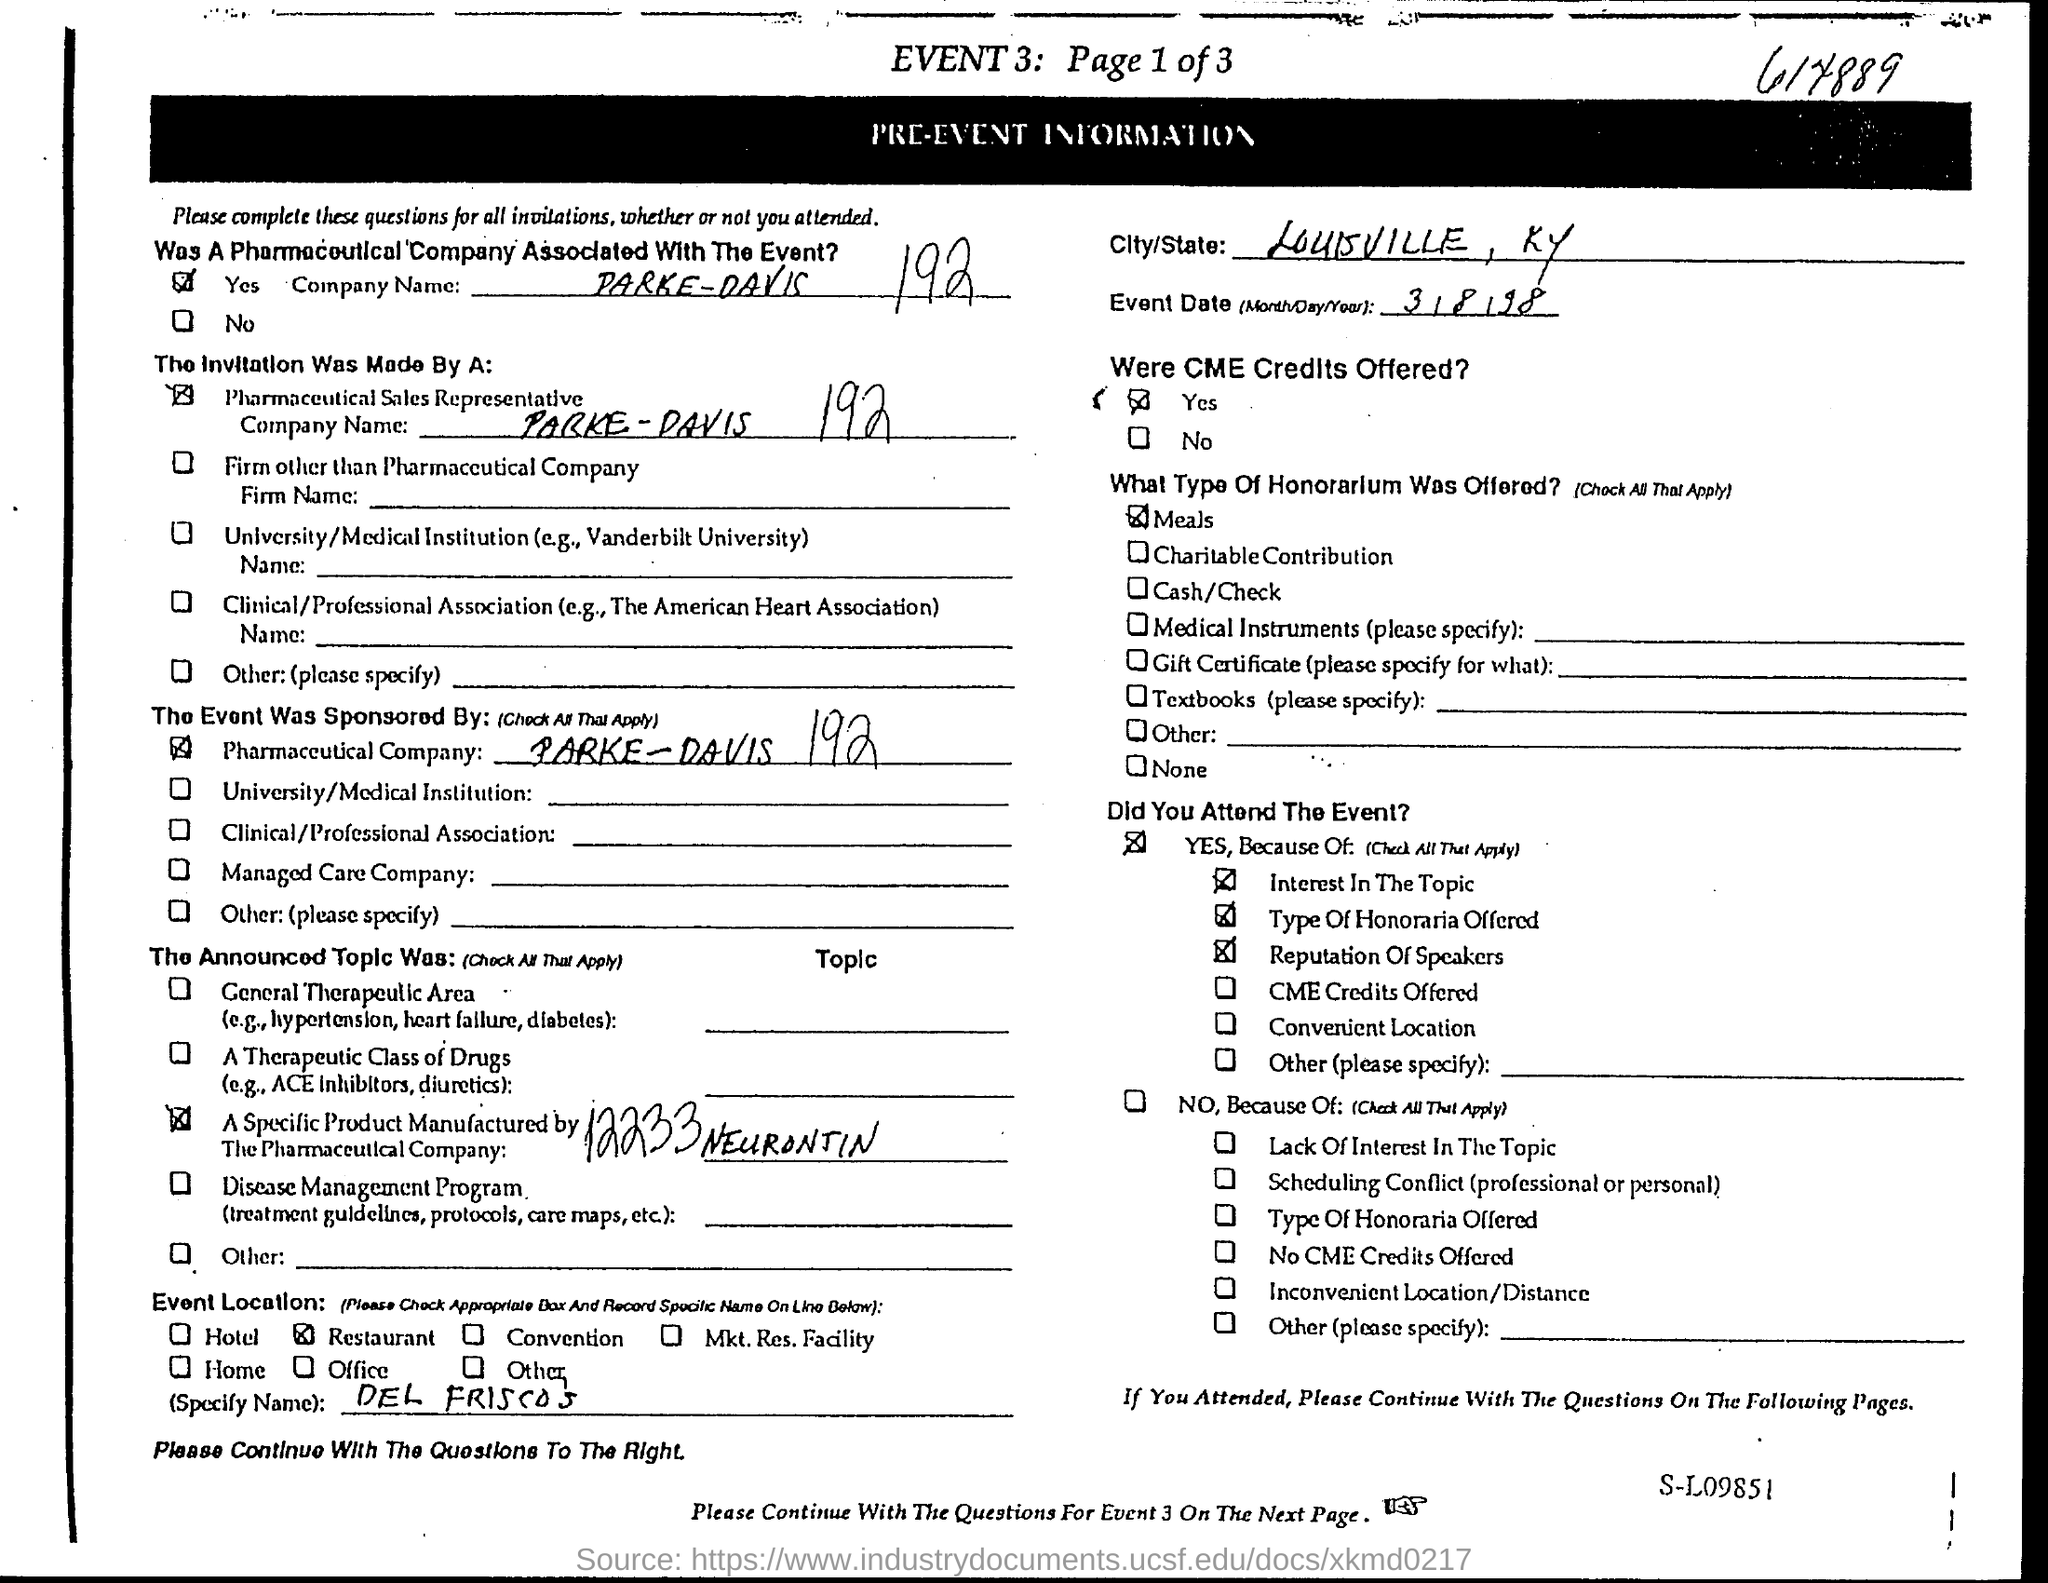Outline some significant characteristics in this image. It was announced that honorarium was offered in the form of meals. On which date is the event taking place? 